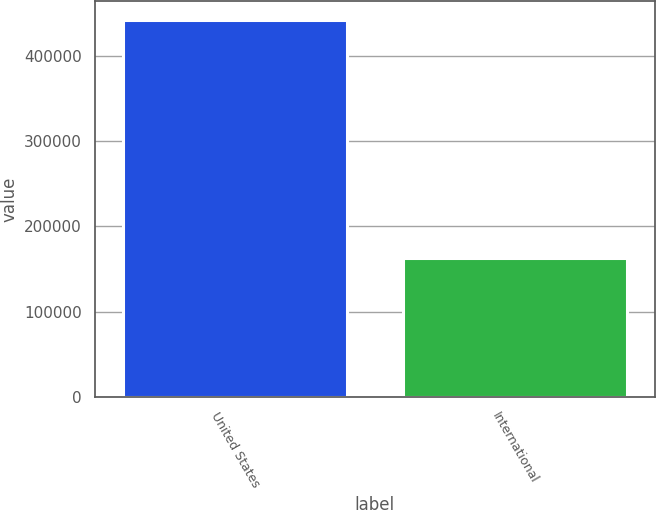Convert chart. <chart><loc_0><loc_0><loc_500><loc_500><bar_chart><fcel>United States<fcel>International<nl><fcel>441336<fcel>162424<nl></chart> 